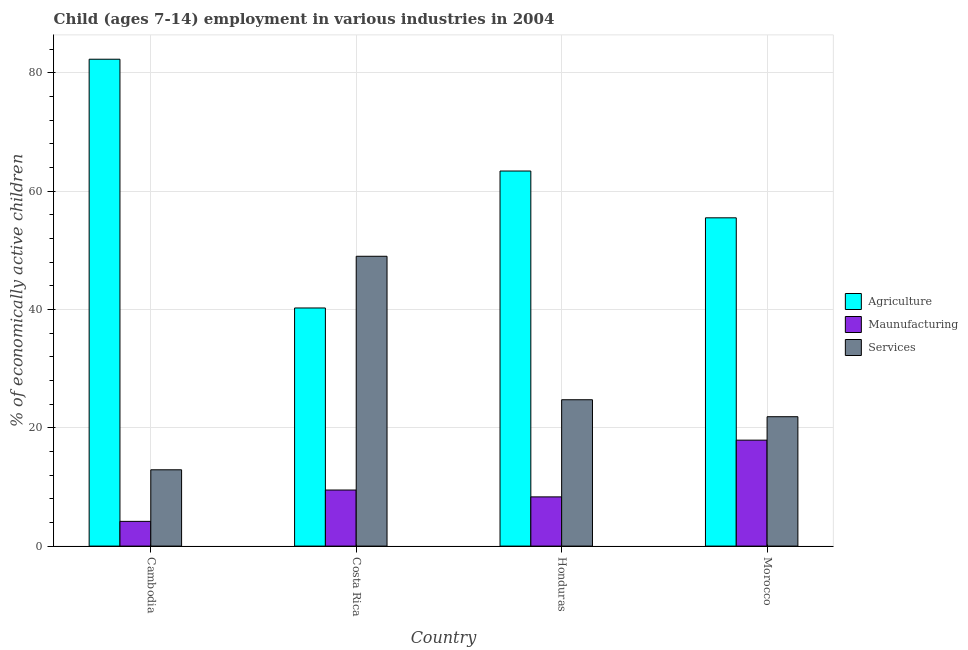What is the label of the 4th group of bars from the left?
Offer a terse response. Morocco. In how many cases, is the number of bars for a given country not equal to the number of legend labels?
Your response must be concise. 0. What is the percentage of economically active children in agriculture in Morocco?
Provide a short and direct response. 55.49. Across all countries, what is the maximum percentage of economically active children in manufacturing?
Provide a succinct answer. 17.91. Across all countries, what is the minimum percentage of economically active children in services?
Make the answer very short. 12.9. In which country was the percentage of economically active children in agriculture minimum?
Make the answer very short. Costa Rica. What is the total percentage of economically active children in agriculture in the graph?
Your response must be concise. 241.44. What is the difference between the percentage of economically active children in agriculture in Costa Rica and that in Honduras?
Make the answer very short. -23.15. What is the difference between the percentage of economically active children in services in Cambodia and the percentage of economically active children in manufacturing in Honduras?
Ensure brevity in your answer.  4.58. What is the average percentage of economically active children in manufacturing per country?
Provide a short and direct response. 9.97. What is the difference between the percentage of economically active children in manufacturing and percentage of economically active children in services in Honduras?
Offer a very short reply. -16.42. What is the ratio of the percentage of economically active children in services in Cambodia to that in Honduras?
Keep it short and to the point. 0.52. Is the percentage of economically active children in manufacturing in Cambodia less than that in Costa Rica?
Offer a terse response. Yes. What is the difference between the highest and the second highest percentage of economically active children in services?
Make the answer very short. 24.25. What is the difference between the highest and the lowest percentage of economically active children in agriculture?
Keep it short and to the point. 42.05. Is the sum of the percentage of economically active children in agriculture in Cambodia and Honduras greater than the maximum percentage of economically active children in manufacturing across all countries?
Your answer should be compact. Yes. What does the 2nd bar from the left in Morocco represents?
Provide a short and direct response. Maunufacturing. What does the 2nd bar from the right in Cambodia represents?
Make the answer very short. Maunufacturing. How many bars are there?
Give a very brief answer. 12. How many countries are there in the graph?
Your response must be concise. 4. Where does the legend appear in the graph?
Keep it short and to the point. Center right. How are the legend labels stacked?
Provide a short and direct response. Vertical. What is the title of the graph?
Make the answer very short. Child (ages 7-14) employment in various industries in 2004. Does "Manufactures" appear as one of the legend labels in the graph?
Provide a succinct answer. No. What is the label or title of the X-axis?
Ensure brevity in your answer.  Country. What is the label or title of the Y-axis?
Give a very brief answer. % of economically active children. What is the % of economically active children of Agriculture in Cambodia?
Provide a short and direct response. 82.3. What is the % of economically active children in Maunufacturing in Cambodia?
Give a very brief answer. 4.18. What is the % of economically active children of Agriculture in Costa Rica?
Keep it short and to the point. 40.25. What is the % of economically active children in Maunufacturing in Costa Rica?
Offer a very short reply. 9.48. What is the % of economically active children in Services in Costa Rica?
Ensure brevity in your answer.  48.99. What is the % of economically active children of Agriculture in Honduras?
Offer a terse response. 63.4. What is the % of economically active children of Maunufacturing in Honduras?
Offer a terse response. 8.32. What is the % of economically active children in Services in Honduras?
Provide a short and direct response. 24.74. What is the % of economically active children in Agriculture in Morocco?
Provide a succinct answer. 55.49. What is the % of economically active children in Maunufacturing in Morocco?
Offer a terse response. 17.91. What is the % of economically active children of Services in Morocco?
Offer a terse response. 21.87. Across all countries, what is the maximum % of economically active children of Agriculture?
Offer a terse response. 82.3. Across all countries, what is the maximum % of economically active children in Maunufacturing?
Give a very brief answer. 17.91. Across all countries, what is the maximum % of economically active children of Services?
Keep it short and to the point. 48.99. Across all countries, what is the minimum % of economically active children in Agriculture?
Offer a very short reply. 40.25. Across all countries, what is the minimum % of economically active children of Maunufacturing?
Give a very brief answer. 4.18. Across all countries, what is the minimum % of economically active children in Services?
Offer a terse response. 12.9. What is the total % of economically active children in Agriculture in the graph?
Provide a short and direct response. 241.44. What is the total % of economically active children of Maunufacturing in the graph?
Provide a short and direct response. 39.89. What is the total % of economically active children of Services in the graph?
Give a very brief answer. 108.5. What is the difference between the % of economically active children in Agriculture in Cambodia and that in Costa Rica?
Offer a very short reply. 42.05. What is the difference between the % of economically active children in Services in Cambodia and that in Costa Rica?
Give a very brief answer. -36.09. What is the difference between the % of economically active children in Maunufacturing in Cambodia and that in Honduras?
Offer a terse response. -4.14. What is the difference between the % of economically active children of Services in Cambodia and that in Honduras?
Give a very brief answer. -11.84. What is the difference between the % of economically active children of Agriculture in Cambodia and that in Morocco?
Your response must be concise. 26.81. What is the difference between the % of economically active children in Maunufacturing in Cambodia and that in Morocco?
Provide a succinct answer. -13.73. What is the difference between the % of economically active children in Services in Cambodia and that in Morocco?
Make the answer very short. -8.97. What is the difference between the % of economically active children in Agriculture in Costa Rica and that in Honduras?
Provide a succinct answer. -23.15. What is the difference between the % of economically active children of Maunufacturing in Costa Rica and that in Honduras?
Your answer should be very brief. 1.16. What is the difference between the % of economically active children of Services in Costa Rica and that in Honduras?
Make the answer very short. 24.25. What is the difference between the % of economically active children in Agriculture in Costa Rica and that in Morocco?
Ensure brevity in your answer.  -15.24. What is the difference between the % of economically active children in Maunufacturing in Costa Rica and that in Morocco?
Your response must be concise. -8.43. What is the difference between the % of economically active children of Services in Costa Rica and that in Morocco?
Provide a succinct answer. 27.12. What is the difference between the % of economically active children of Agriculture in Honduras and that in Morocco?
Keep it short and to the point. 7.91. What is the difference between the % of economically active children of Maunufacturing in Honduras and that in Morocco?
Your response must be concise. -9.59. What is the difference between the % of economically active children in Services in Honduras and that in Morocco?
Keep it short and to the point. 2.87. What is the difference between the % of economically active children in Agriculture in Cambodia and the % of economically active children in Maunufacturing in Costa Rica?
Make the answer very short. 72.82. What is the difference between the % of economically active children in Agriculture in Cambodia and the % of economically active children in Services in Costa Rica?
Your answer should be compact. 33.31. What is the difference between the % of economically active children in Maunufacturing in Cambodia and the % of economically active children in Services in Costa Rica?
Ensure brevity in your answer.  -44.81. What is the difference between the % of economically active children of Agriculture in Cambodia and the % of economically active children of Maunufacturing in Honduras?
Offer a terse response. 73.98. What is the difference between the % of economically active children in Agriculture in Cambodia and the % of economically active children in Services in Honduras?
Keep it short and to the point. 57.56. What is the difference between the % of economically active children in Maunufacturing in Cambodia and the % of economically active children in Services in Honduras?
Offer a terse response. -20.56. What is the difference between the % of economically active children of Agriculture in Cambodia and the % of economically active children of Maunufacturing in Morocco?
Make the answer very short. 64.39. What is the difference between the % of economically active children in Agriculture in Cambodia and the % of economically active children in Services in Morocco?
Keep it short and to the point. 60.43. What is the difference between the % of economically active children of Maunufacturing in Cambodia and the % of economically active children of Services in Morocco?
Provide a short and direct response. -17.69. What is the difference between the % of economically active children in Agriculture in Costa Rica and the % of economically active children in Maunufacturing in Honduras?
Offer a terse response. 31.93. What is the difference between the % of economically active children in Agriculture in Costa Rica and the % of economically active children in Services in Honduras?
Ensure brevity in your answer.  15.51. What is the difference between the % of economically active children of Maunufacturing in Costa Rica and the % of economically active children of Services in Honduras?
Your answer should be compact. -15.26. What is the difference between the % of economically active children of Agriculture in Costa Rica and the % of economically active children of Maunufacturing in Morocco?
Provide a succinct answer. 22.34. What is the difference between the % of economically active children of Agriculture in Costa Rica and the % of economically active children of Services in Morocco?
Your answer should be very brief. 18.38. What is the difference between the % of economically active children of Maunufacturing in Costa Rica and the % of economically active children of Services in Morocco?
Keep it short and to the point. -12.39. What is the difference between the % of economically active children in Agriculture in Honduras and the % of economically active children in Maunufacturing in Morocco?
Give a very brief answer. 45.49. What is the difference between the % of economically active children of Agriculture in Honduras and the % of economically active children of Services in Morocco?
Offer a terse response. 41.53. What is the difference between the % of economically active children in Maunufacturing in Honduras and the % of economically active children in Services in Morocco?
Ensure brevity in your answer.  -13.55. What is the average % of economically active children of Agriculture per country?
Your response must be concise. 60.36. What is the average % of economically active children of Maunufacturing per country?
Keep it short and to the point. 9.97. What is the average % of economically active children of Services per country?
Give a very brief answer. 27.12. What is the difference between the % of economically active children of Agriculture and % of economically active children of Maunufacturing in Cambodia?
Provide a short and direct response. 78.12. What is the difference between the % of economically active children in Agriculture and % of economically active children in Services in Cambodia?
Your answer should be compact. 69.4. What is the difference between the % of economically active children of Maunufacturing and % of economically active children of Services in Cambodia?
Ensure brevity in your answer.  -8.72. What is the difference between the % of economically active children in Agriculture and % of economically active children in Maunufacturing in Costa Rica?
Your answer should be compact. 30.77. What is the difference between the % of economically active children in Agriculture and % of economically active children in Services in Costa Rica?
Offer a terse response. -8.74. What is the difference between the % of economically active children in Maunufacturing and % of economically active children in Services in Costa Rica?
Keep it short and to the point. -39.51. What is the difference between the % of economically active children in Agriculture and % of economically active children in Maunufacturing in Honduras?
Make the answer very short. 55.08. What is the difference between the % of economically active children in Agriculture and % of economically active children in Services in Honduras?
Your response must be concise. 38.66. What is the difference between the % of economically active children of Maunufacturing and % of economically active children of Services in Honduras?
Give a very brief answer. -16.42. What is the difference between the % of economically active children in Agriculture and % of economically active children in Maunufacturing in Morocco?
Your response must be concise. 37.58. What is the difference between the % of economically active children in Agriculture and % of economically active children in Services in Morocco?
Ensure brevity in your answer.  33.62. What is the difference between the % of economically active children in Maunufacturing and % of economically active children in Services in Morocco?
Provide a succinct answer. -3.96. What is the ratio of the % of economically active children in Agriculture in Cambodia to that in Costa Rica?
Provide a succinct answer. 2.04. What is the ratio of the % of economically active children in Maunufacturing in Cambodia to that in Costa Rica?
Offer a terse response. 0.44. What is the ratio of the % of economically active children in Services in Cambodia to that in Costa Rica?
Your answer should be compact. 0.26. What is the ratio of the % of economically active children in Agriculture in Cambodia to that in Honduras?
Ensure brevity in your answer.  1.3. What is the ratio of the % of economically active children in Maunufacturing in Cambodia to that in Honduras?
Your response must be concise. 0.5. What is the ratio of the % of economically active children in Services in Cambodia to that in Honduras?
Provide a short and direct response. 0.52. What is the ratio of the % of economically active children in Agriculture in Cambodia to that in Morocco?
Keep it short and to the point. 1.48. What is the ratio of the % of economically active children in Maunufacturing in Cambodia to that in Morocco?
Provide a succinct answer. 0.23. What is the ratio of the % of economically active children of Services in Cambodia to that in Morocco?
Your response must be concise. 0.59. What is the ratio of the % of economically active children of Agriculture in Costa Rica to that in Honduras?
Ensure brevity in your answer.  0.63. What is the ratio of the % of economically active children in Maunufacturing in Costa Rica to that in Honduras?
Offer a very short reply. 1.14. What is the ratio of the % of economically active children in Services in Costa Rica to that in Honduras?
Your answer should be compact. 1.98. What is the ratio of the % of economically active children of Agriculture in Costa Rica to that in Morocco?
Offer a terse response. 0.73. What is the ratio of the % of economically active children in Maunufacturing in Costa Rica to that in Morocco?
Provide a short and direct response. 0.53. What is the ratio of the % of economically active children of Services in Costa Rica to that in Morocco?
Provide a short and direct response. 2.24. What is the ratio of the % of economically active children in Agriculture in Honduras to that in Morocco?
Your response must be concise. 1.14. What is the ratio of the % of economically active children in Maunufacturing in Honduras to that in Morocco?
Provide a succinct answer. 0.46. What is the ratio of the % of economically active children in Services in Honduras to that in Morocco?
Ensure brevity in your answer.  1.13. What is the difference between the highest and the second highest % of economically active children of Agriculture?
Your answer should be compact. 18.9. What is the difference between the highest and the second highest % of economically active children of Maunufacturing?
Offer a very short reply. 8.43. What is the difference between the highest and the second highest % of economically active children in Services?
Offer a terse response. 24.25. What is the difference between the highest and the lowest % of economically active children of Agriculture?
Give a very brief answer. 42.05. What is the difference between the highest and the lowest % of economically active children of Maunufacturing?
Provide a short and direct response. 13.73. What is the difference between the highest and the lowest % of economically active children of Services?
Provide a succinct answer. 36.09. 